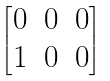<formula> <loc_0><loc_0><loc_500><loc_500>\begin{bmatrix} 0 & 0 & 0 \\ 1 & 0 & 0 \end{bmatrix}</formula> 